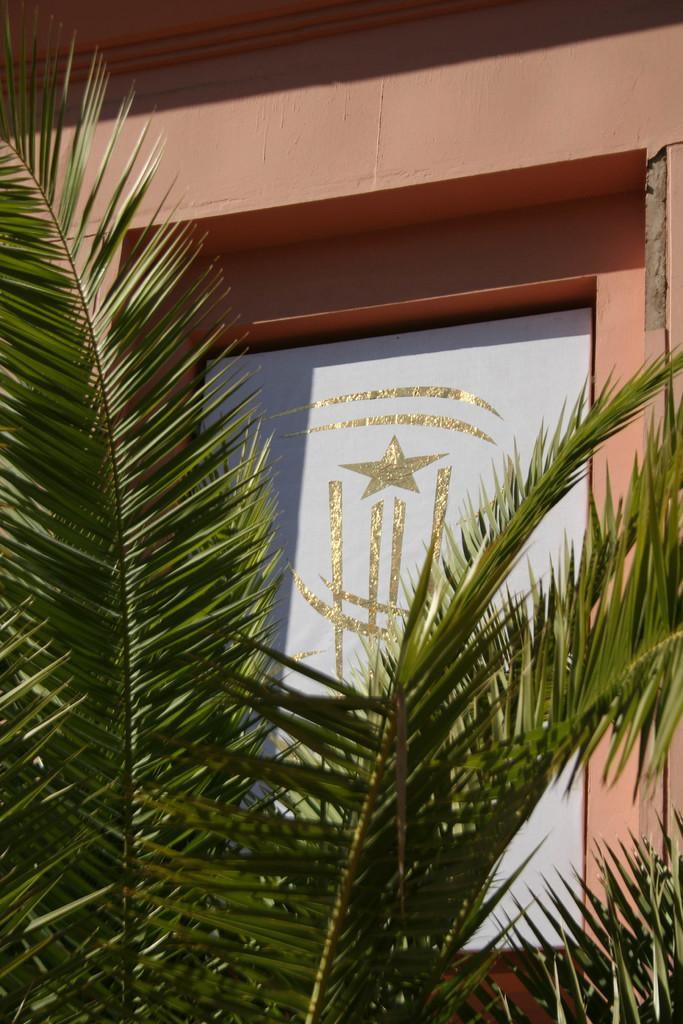What type of vegetation is visible in the image? There are green leaves of a tree in the image. What is the color of the star on the white color board? The star on the white color board is gold in color. What is the color of the wall in the image? The wall in the image is cream in color. Is there any quicksand visible in the image? No, there is no quicksand present in the image. Where is the nearest park to the location depicted in the image? The image does not provide enough information to determine the location, so we cannot determine the nearest park. 